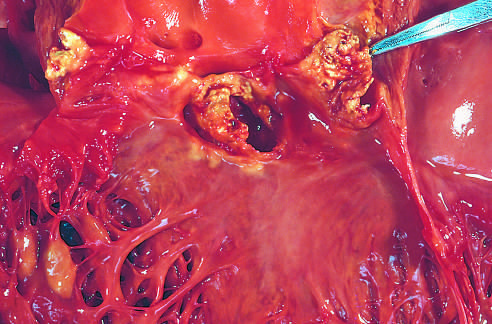s acid-fast caused by staphylococcus aureus on a congenitally bicuspid aortic valve with extensive cuspal destruction and ring abscess?
Answer the question using a single word or phrase. No 